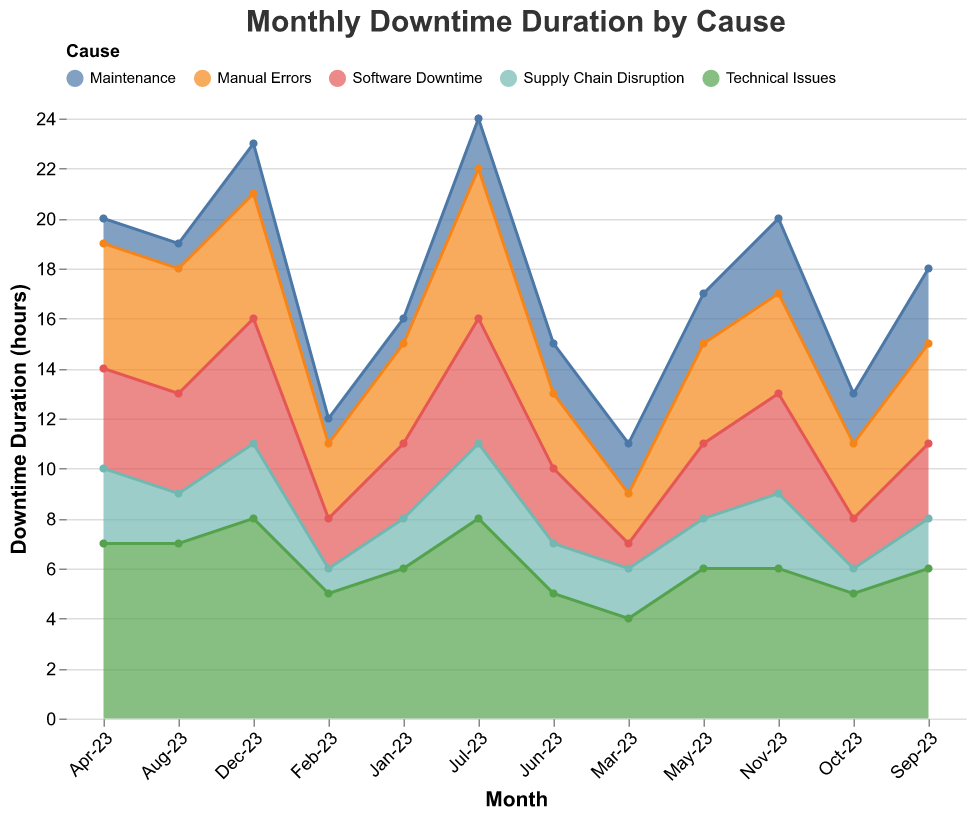What is the title of the figure? The title is located at the top of the chart and generally provides an overall description. The title here is "Monthly Downtime Duration by Cause".
Answer: Monthly Downtime Duration by Cause How many categories of downtime causes are represented in the chart? To answer this question, count the distinct categories displayed in the color legend. The categories are Technical Issues, Manual Errors, Supply Chain Disruption, Maintenance, and Software Downtime.
Answer: 5 Which month had the highest total downtime due to Technical Issues? Look at the area corresponding to Technical Issues (identified by its color in the legend) and find the peak value month. According to the data and chart, it is either April, July, or December. Verify by checking the data table.
Answer: July or December What is the total downtime attributed to Maintenance in the month of September? Locate September on the x-axis, then refer to the area section representing Maintenance. The value is given directly by the data, which is 3 hours.
Answer: 3 hours Compare the downtime duration of Software Downtime between July-23 and December-23. Which month had the higher downtime? Find the sections for Software Downtime in July and December. According to the chart, Software Downtime in July is 5 hours and in December it is also 5 hours.
Answer: Both months have equal downtime Which month recorded the lowest downtime caused by Supply Chain Disruption? Find the smallest area for Supply Chain Disruption. According to the data and chart, the value is the lowest in February and October (1 hour).
Answer: February or October What is the average monthly downtime for Manual Errors over the year? First, find and sum the values for Manual Errors in each month, then divide by the number of months (12). The sum is (4+3+2+5+4+3+6+5+4+3+4+5) = 48 hours, so the average is 48/12.
Answer: 4 hours In which month did Supply Chain Disruption and Maintenance combined account for the highest downtime? Sum up the downtime for Supply Chain Disruption and Maintenance for each month. By comparing these sums, find the highest. From the data, November (3+3=6) and September (2+3=5) stand out.
Answer: November What is the trend of Technical Issues' downtime from January to December? Observe the general direction of the area corresponding to Technical Issues across the months. Overall, the downtime increases and then fluctuates slightly towards the end of the year.
Answer: Increasing then fluctuating Between which two consecutive months did Manual Errors see the largest increase in downtime? Calculate the difference for Manual Errors between each consecutive month and find the largest positive difference. The difference is largest between June (3) and July (6), with an increase of 3 hours.
Answer: June to July 